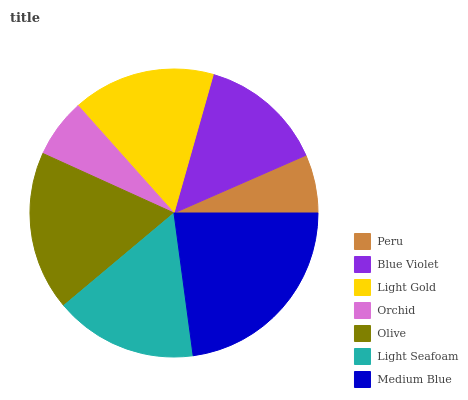Is Peru the minimum?
Answer yes or no. Yes. Is Medium Blue the maximum?
Answer yes or no. Yes. Is Blue Violet the minimum?
Answer yes or no. No. Is Blue Violet the maximum?
Answer yes or no. No. Is Blue Violet greater than Peru?
Answer yes or no. Yes. Is Peru less than Blue Violet?
Answer yes or no. Yes. Is Peru greater than Blue Violet?
Answer yes or no. No. Is Blue Violet less than Peru?
Answer yes or no. No. Is Light Gold the high median?
Answer yes or no. Yes. Is Light Gold the low median?
Answer yes or no. Yes. Is Light Seafoam the high median?
Answer yes or no. No. Is Blue Violet the low median?
Answer yes or no. No. 